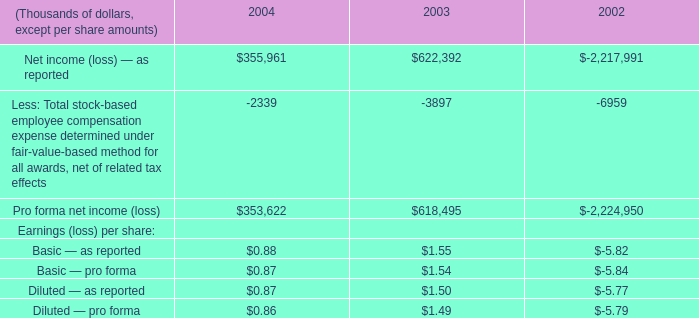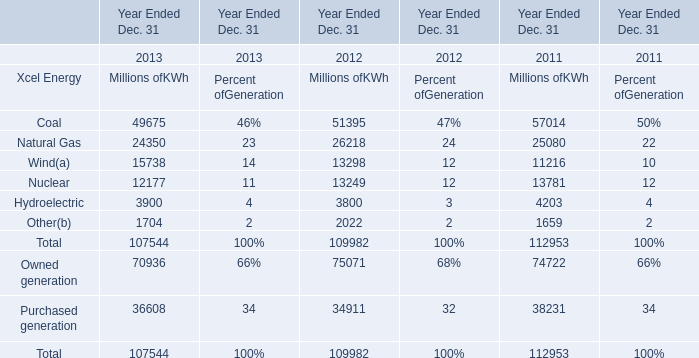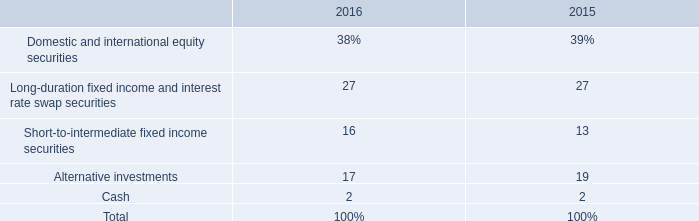What's the average of Xcel Energy in 2012? (in million) 
Computations: ((((((51395 + 26218) + 13298) + 13249) + 3800) + 2022) / 6)
Answer: 18330.33333. 